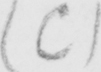Can you read and transcribe this handwriting? ( C ) 